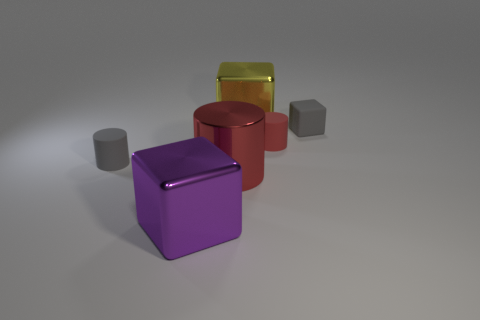Subtract all metallic blocks. How many blocks are left? 1 Subtract all gray cubes. How many cubes are left? 2 Subtract 2 blocks. How many blocks are left? 1 Add 4 red cylinders. How many objects exist? 10 Subtract all blue cylinders. How many cyan blocks are left? 0 Subtract all small brown rubber cubes. Subtract all red metallic objects. How many objects are left? 5 Add 1 gray matte cylinders. How many gray matte cylinders are left? 2 Add 4 large yellow metallic cubes. How many large yellow metallic cubes exist? 5 Subtract 0 red cubes. How many objects are left? 6 Subtract all gray cubes. Subtract all red spheres. How many cubes are left? 2 